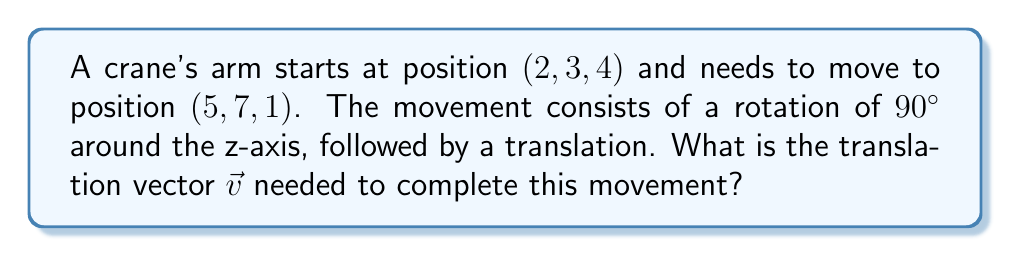Solve this math problem. Let's approach this step-by-step:

1) First, we need to represent the rotation around the z-axis. The rotation matrix for a $90°$ (or $\frac{\pi}{2}$ radians) counterclockwise rotation around the z-axis is:

   $$R_z = \begin{pmatrix}
   0 & -1 & 0 \\
   1 & 0 & 0 \\
   0 & 0 & 1
   \end{pmatrix}$$

2) Apply this rotation to the initial position:

   $$\begin{pmatrix}
   0 & -1 & 0 \\
   1 & 0 & 0 \\
   0 & 0 & 1
   \end{pmatrix} \begin{pmatrix}
   2 \\
   3 \\
   4
   \end{pmatrix} = \begin{pmatrix}
   -3 \\
   2 \\
   4
   \end{pmatrix}$$

3) Now, we need to find the translation vector $\vec{v}$ that will move the crane arm from $(-3, 2, 4)$ to the final position $(5, 7, 1)$.

4) The translation vector is the difference between the final position and the position after rotation:

   $$\vec{v} = \begin{pmatrix}
   5 \\
   7 \\
   1
   \end{pmatrix} - \begin{pmatrix}
   -3 \\
   2 \\
   4
   \end{pmatrix} = \begin{pmatrix}
   5 - (-3) \\
   7 - 2 \\
   1 - 4
   \end{pmatrix} = \begin{pmatrix}
   8 \\
   5 \\
   -3
   \end{pmatrix}$$

Therefore, the translation vector $\vec{v}$ is $(8, 5, -3)$.
Answer: $(8, 5, -3)$ 